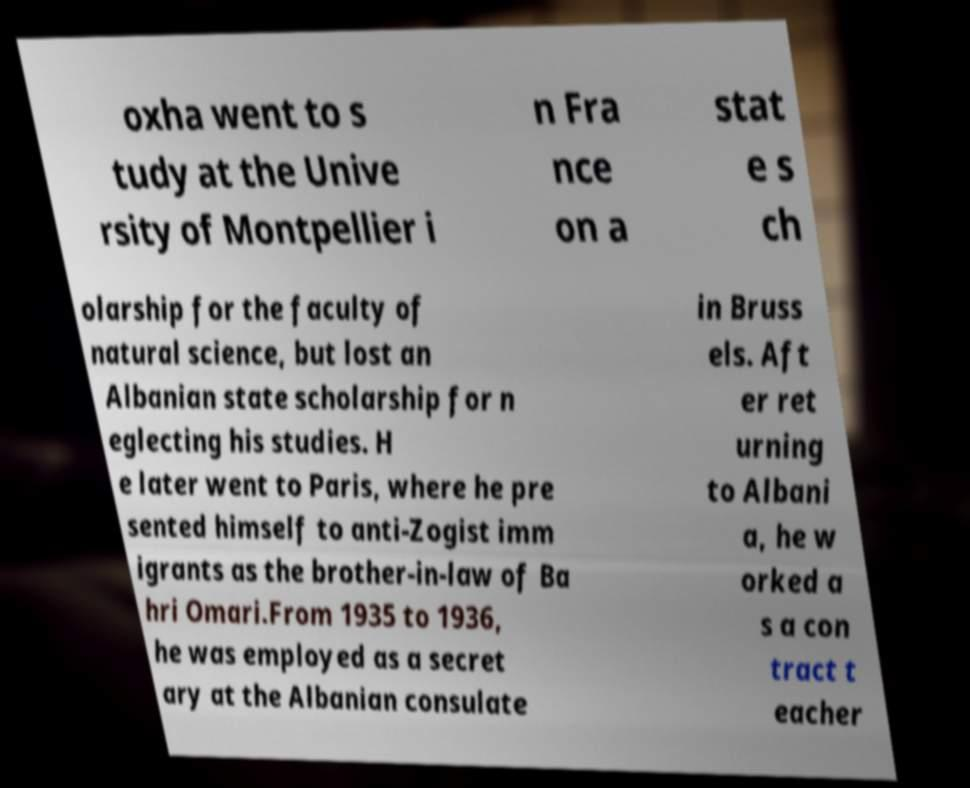I need the written content from this picture converted into text. Can you do that? oxha went to s tudy at the Unive rsity of Montpellier i n Fra nce on a stat e s ch olarship for the faculty of natural science, but lost an Albanian state scholarship for n eglecting his studies. H e later went to Paris, where he pre sented himself to anti-Zogist imm igrants as the brother-in-law of Ba hri Omari.From 1935 to 1936, he was employed as a secret ary at the Albanian consulate in Bruss els. Aft er ret urning to Albani a, he w orked a s a con tract t eacher 